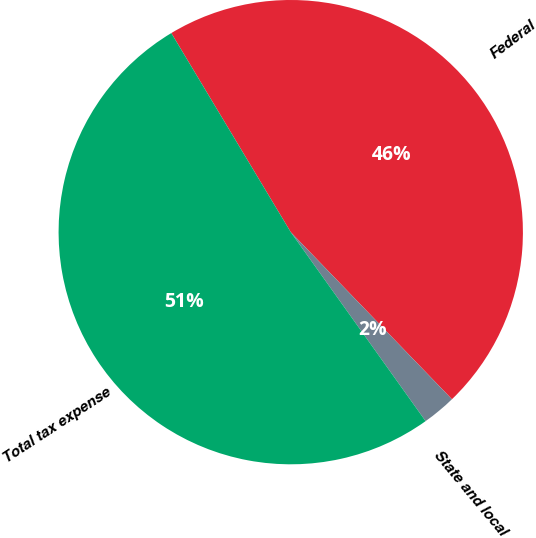Convert chart. <chart><loc_0><loc_0><loc_500><loc_500><pie_chart><fcel>Federal<fcel>State and local<fcel>Total tax expense<nl><fcel>46.39%<fcel>2.35%<fcel>51.26%<nl></chart> 